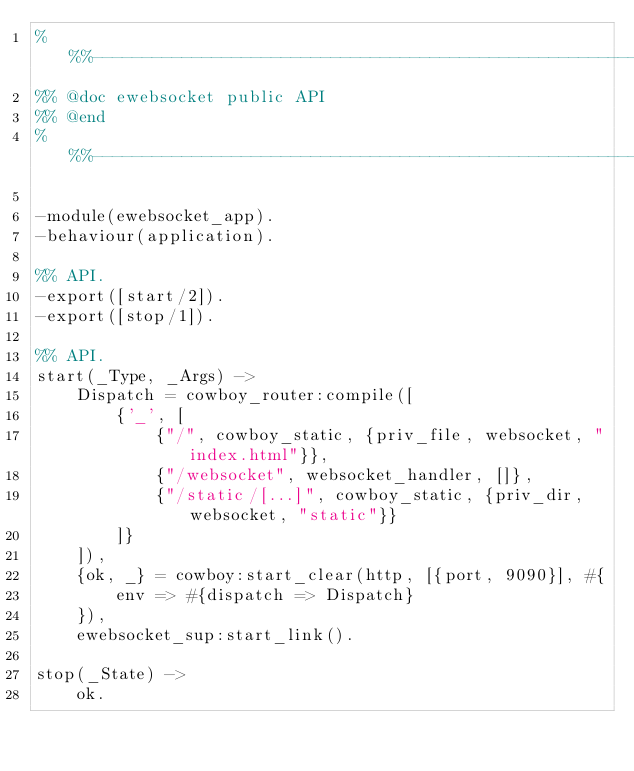Convert code to text. <code><loc_0><loc_0><loc_500><loc_500><_Erlang_>%%%-------------------------------------------------------------------
%% @doc ewebsocket public API
%% @end
%%%-------------------------------------------------------------------

-module(ewebsocket_app).
-behaviour(application).

%% API.
-export([start/2]).
-export([stop/1]).

%% API.
start(_Type, _Args) ->
    Dispatch = cowboy_router:compile([
        {'_', [
            {"/", cowboy_static, {priv_file, websocket, "index.html"}},
            {"/websocket", websocket_handler, []},
            {"/static/[...]", cowboy_static, {priv_dir, websocket, "static"}}
        ]}
    ]),
    {ok, _} = cowboy:start_clear(http, [{port, 9090}], #{
        env => #{dispatch => Dispatch}
    }),
    ewebsocket_sup:start_link().

stop(_State) ->
    ok.
</code> 